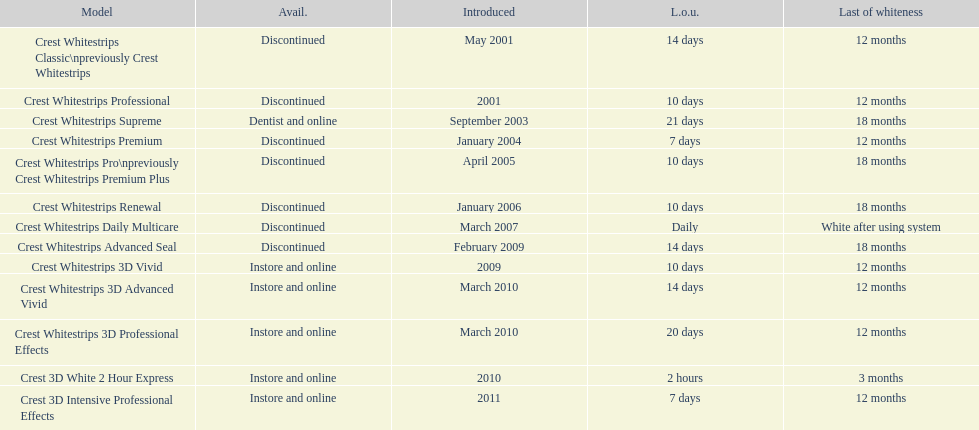For how many models is the required usage period under a week? 2. 